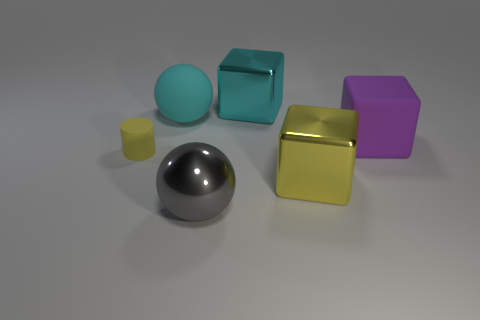What is the material of the purple thing that is the same size as the cyan block?
Your answer should be very brief. Rubber. How big is the sphere that is on the left side of the ball in front of the matte thing in front of the big purple rubber object?
Keep it short and to the point. Large. What number of other objects are there of the same material as the tiny yellow object?
Your answer should be very brief. 2. How big is the rubber thing behind the rubber block?
Offer a terse response. Large. How many objects are behind the tiny matte cylinder and right of the large gray ball?
Offer a terse response. 2. What is the big ball that is to the right of the big matte object that is behind the large purple cube made of?
Provide a short and direct response. Metal. There is another object that is the same shape as the cyan matte object; what is its material?
Keep it short and to the point. Metal. Are there any large things?
Give a very brief answer. Yes. There is a big cyan object that is made of the same material as the large yellow object; what shape is it?
Provide a short and direct response. Cube. There is a big sphere in front of the rubber cylinder; what material is it?
Ensure brevity in your answer.  Metal. 